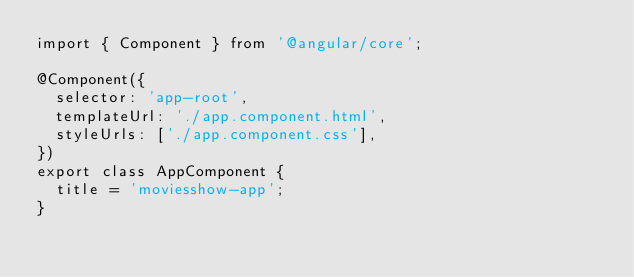<code> <loc_0><loc_0><loc_500><loc_500><_TypeScript_>import { Component } from '@angular/core';

@Component({
  selector: 'app-root',
  templateUrl: './app.component.html',
  styleUrls: ['./app.component.css'],
})
export class AppComponent {
  title = 'moviesshow-app';
}
</code> 